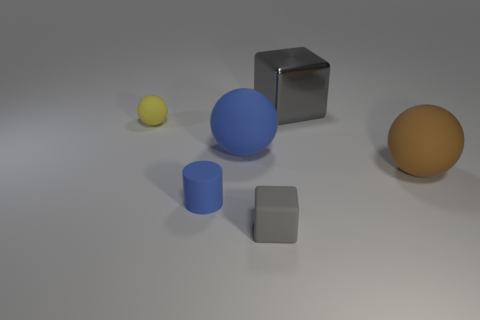Is the large gray object the same shape as the tiny gray rubber thing?
Ensure brevity in your answer.  Yes. There is a sphere that is the same color as the rubber cylinder; what material is it?
Offer a very short reply. Rubber. Does the small matte block have the same color as the shiny object?
Give a very brief answer. Yes. How many big rubber things are to the right of the brown rubber object right of the big rubber thing that is on the left side of the big brown matte thing?
Make the answer very short. 0. What shape is the other large thing that is the same material as the large blue object?
Provide a short and direct response. Sphere. What is the block that is to the right of the gray thing to the left of the gray thing behind the tiny rubber ball made of?
Make the answer very short. Metal. How many objects are either rubber things in front of the small yellow thing or red matte objects?
Provide a succinct answer. 4. What number of other objects are the same shape as the big gray shiny thing?
Your response must be concise. 1. Are there more tiny gray matte objects that are on the left side of the large gray block than cyan blocks?
Offer a terse response. Yes. There is a brown matte thing that is the same shape as the big blue object; what size is it?
Your answer should be very brief. Large. 